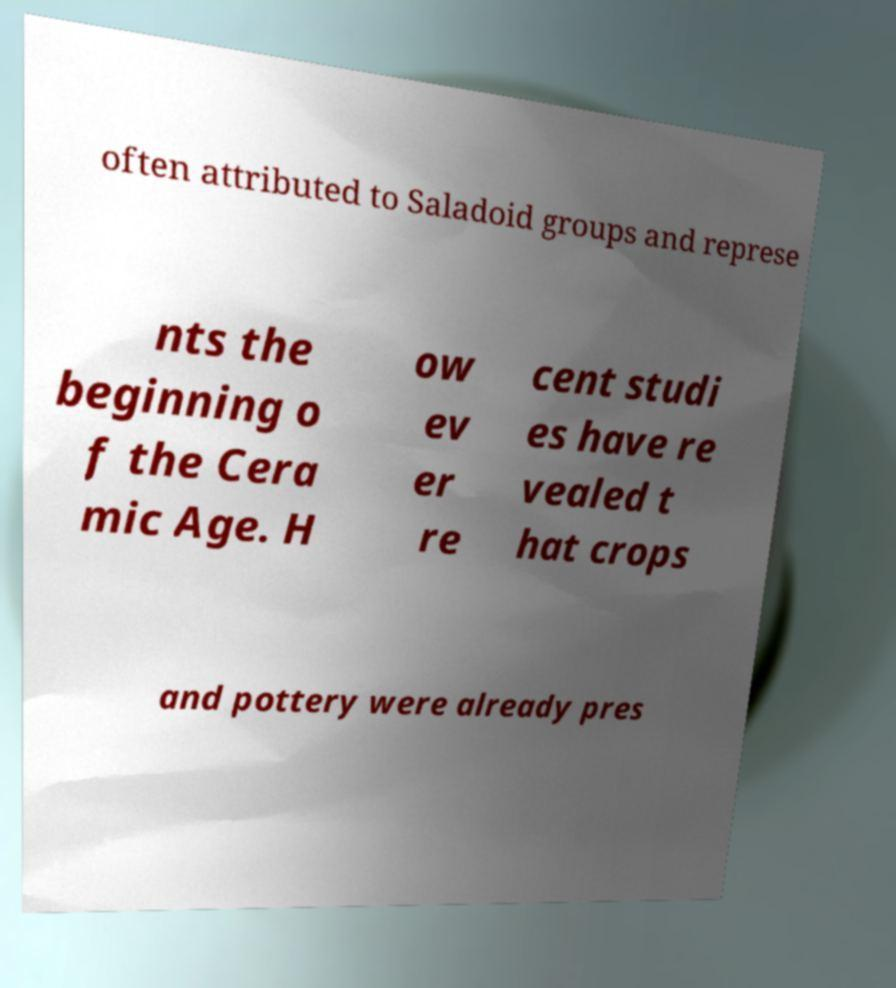I need the written content from this picture converted into text. Can you do that? often attributed to Saladoid groups and represe nts the beginning o f the Cera mic Age. H ow ev er re cent studi es have re vealed t hat crops and pottery were already pres 